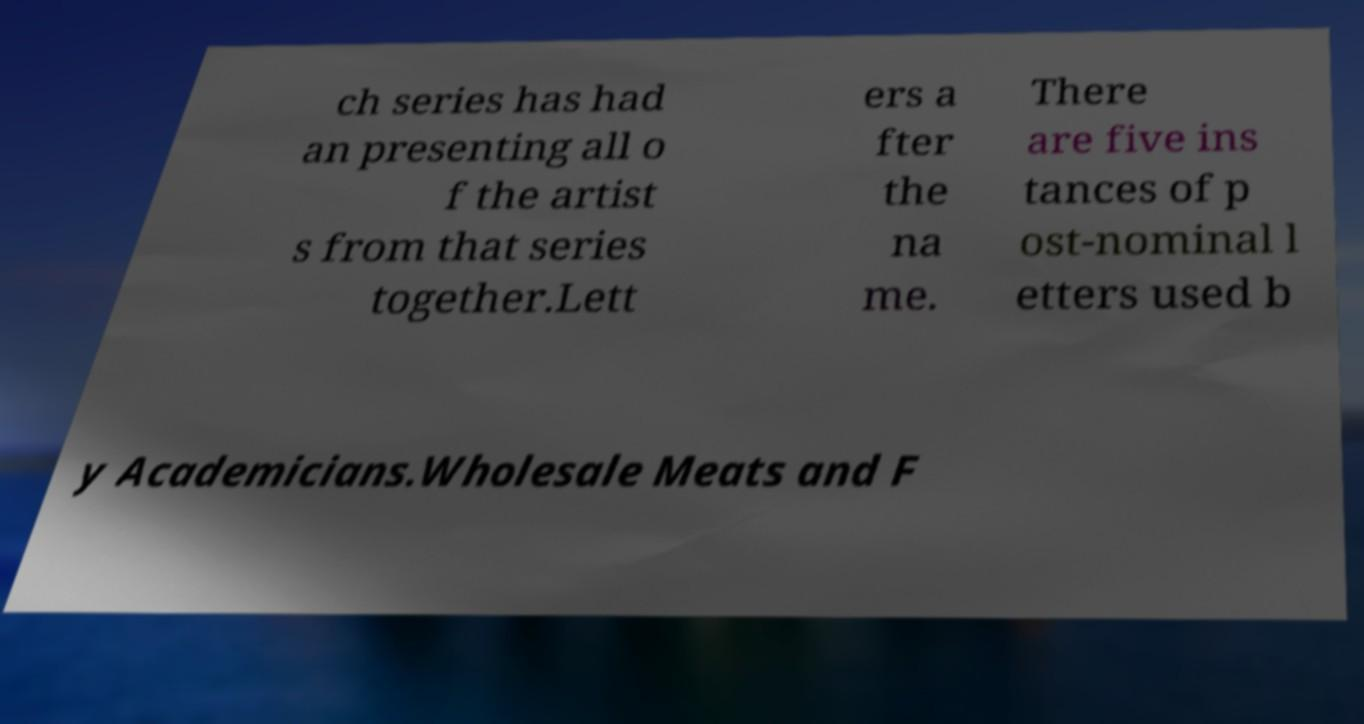Please identify and transcribe the text found in this image. ch series has had an presenting all o f the artist s from that series together.Lett ers a fter the na me. There are five ins tances of p ost-nominal l etters used b y Academicians.Wholesale Meats and F 